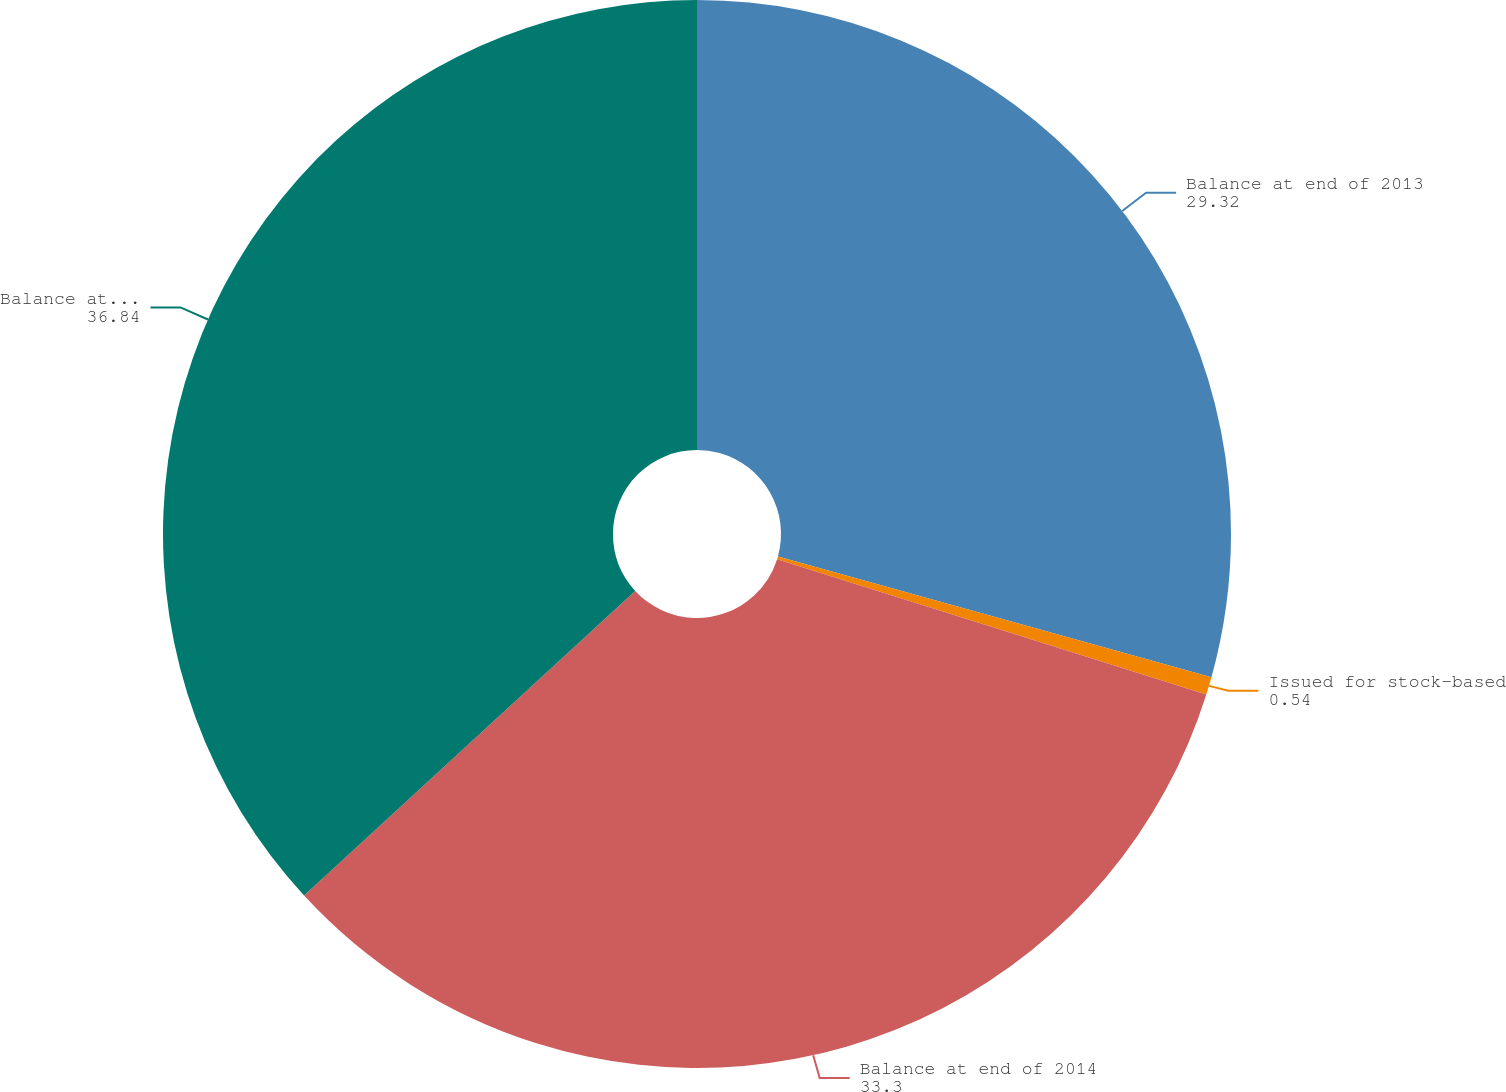Convert chart to OTSL. <chart><loc_0><loc_0><loc_500><loc_500><pie_chart><fcel>Balance at end of 2013<fcel>Issued for stock-based<fcel>Balance at end of 2014<fcel>Balance at end of 2015<nl><fcel>29.32%<fcel>0.54%<fcel>33.3%<fcel>36.84%<nl></chart> 